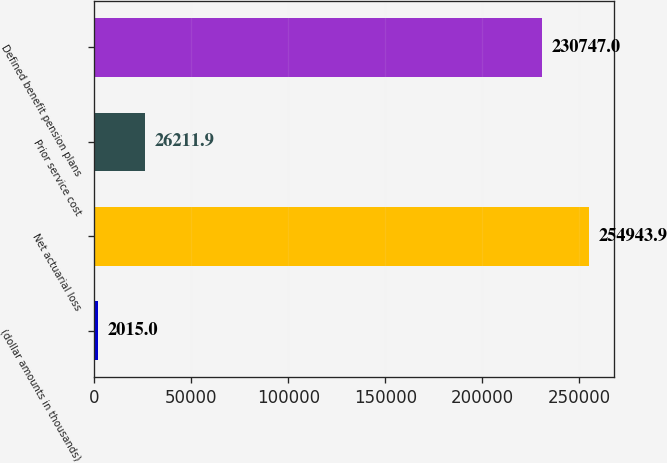Convert chart to OTSL. <chart><loc_0><loc_0><loc_500><loc_500><bar_chart><fcel>(dollar amounts in thousands)<fcel>Net actuarial loss<fcel>Prior service cost<fcel>Defined benefit pension plans<nl><fcel>2015<fcel>254944<fcel>26211.9<fcel>230747<nl></chart> 